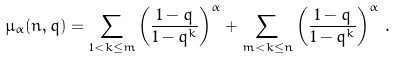Convert formula to latex. <formula><loc_0><loc_0><loc_500><loc_500>\mu _ { \alpha } ( n , q ) & = \sum _ { 1 < k \leq m } \left ( \frac { 1 - q } { 1 - q ^ { k } } \right ) ^ { \alpha } + \sum _ { m < k \leq n } \left ( \frac { 1 - q } { 1 - q ^ { k } } \right ) ^ { \alpha } \, .</formula> 